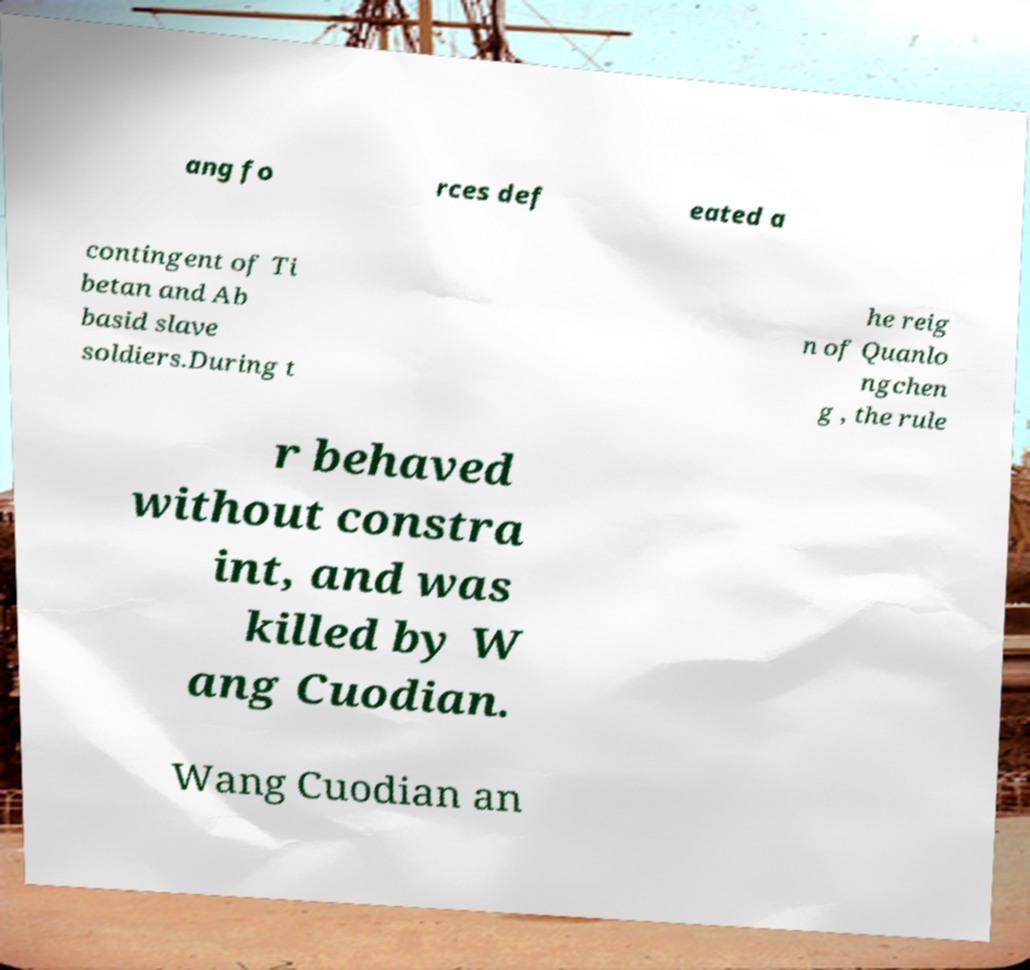Please read and relay the text visible in this image. What does it say? ang fo rces def eated a contingent of Ti betan and Ab basid slave soldiers.During t he reig n of Quanlo ngchen g , the rule r behaved without constra int, and was killed by W ang Cuodian. Wang Cuodian an 